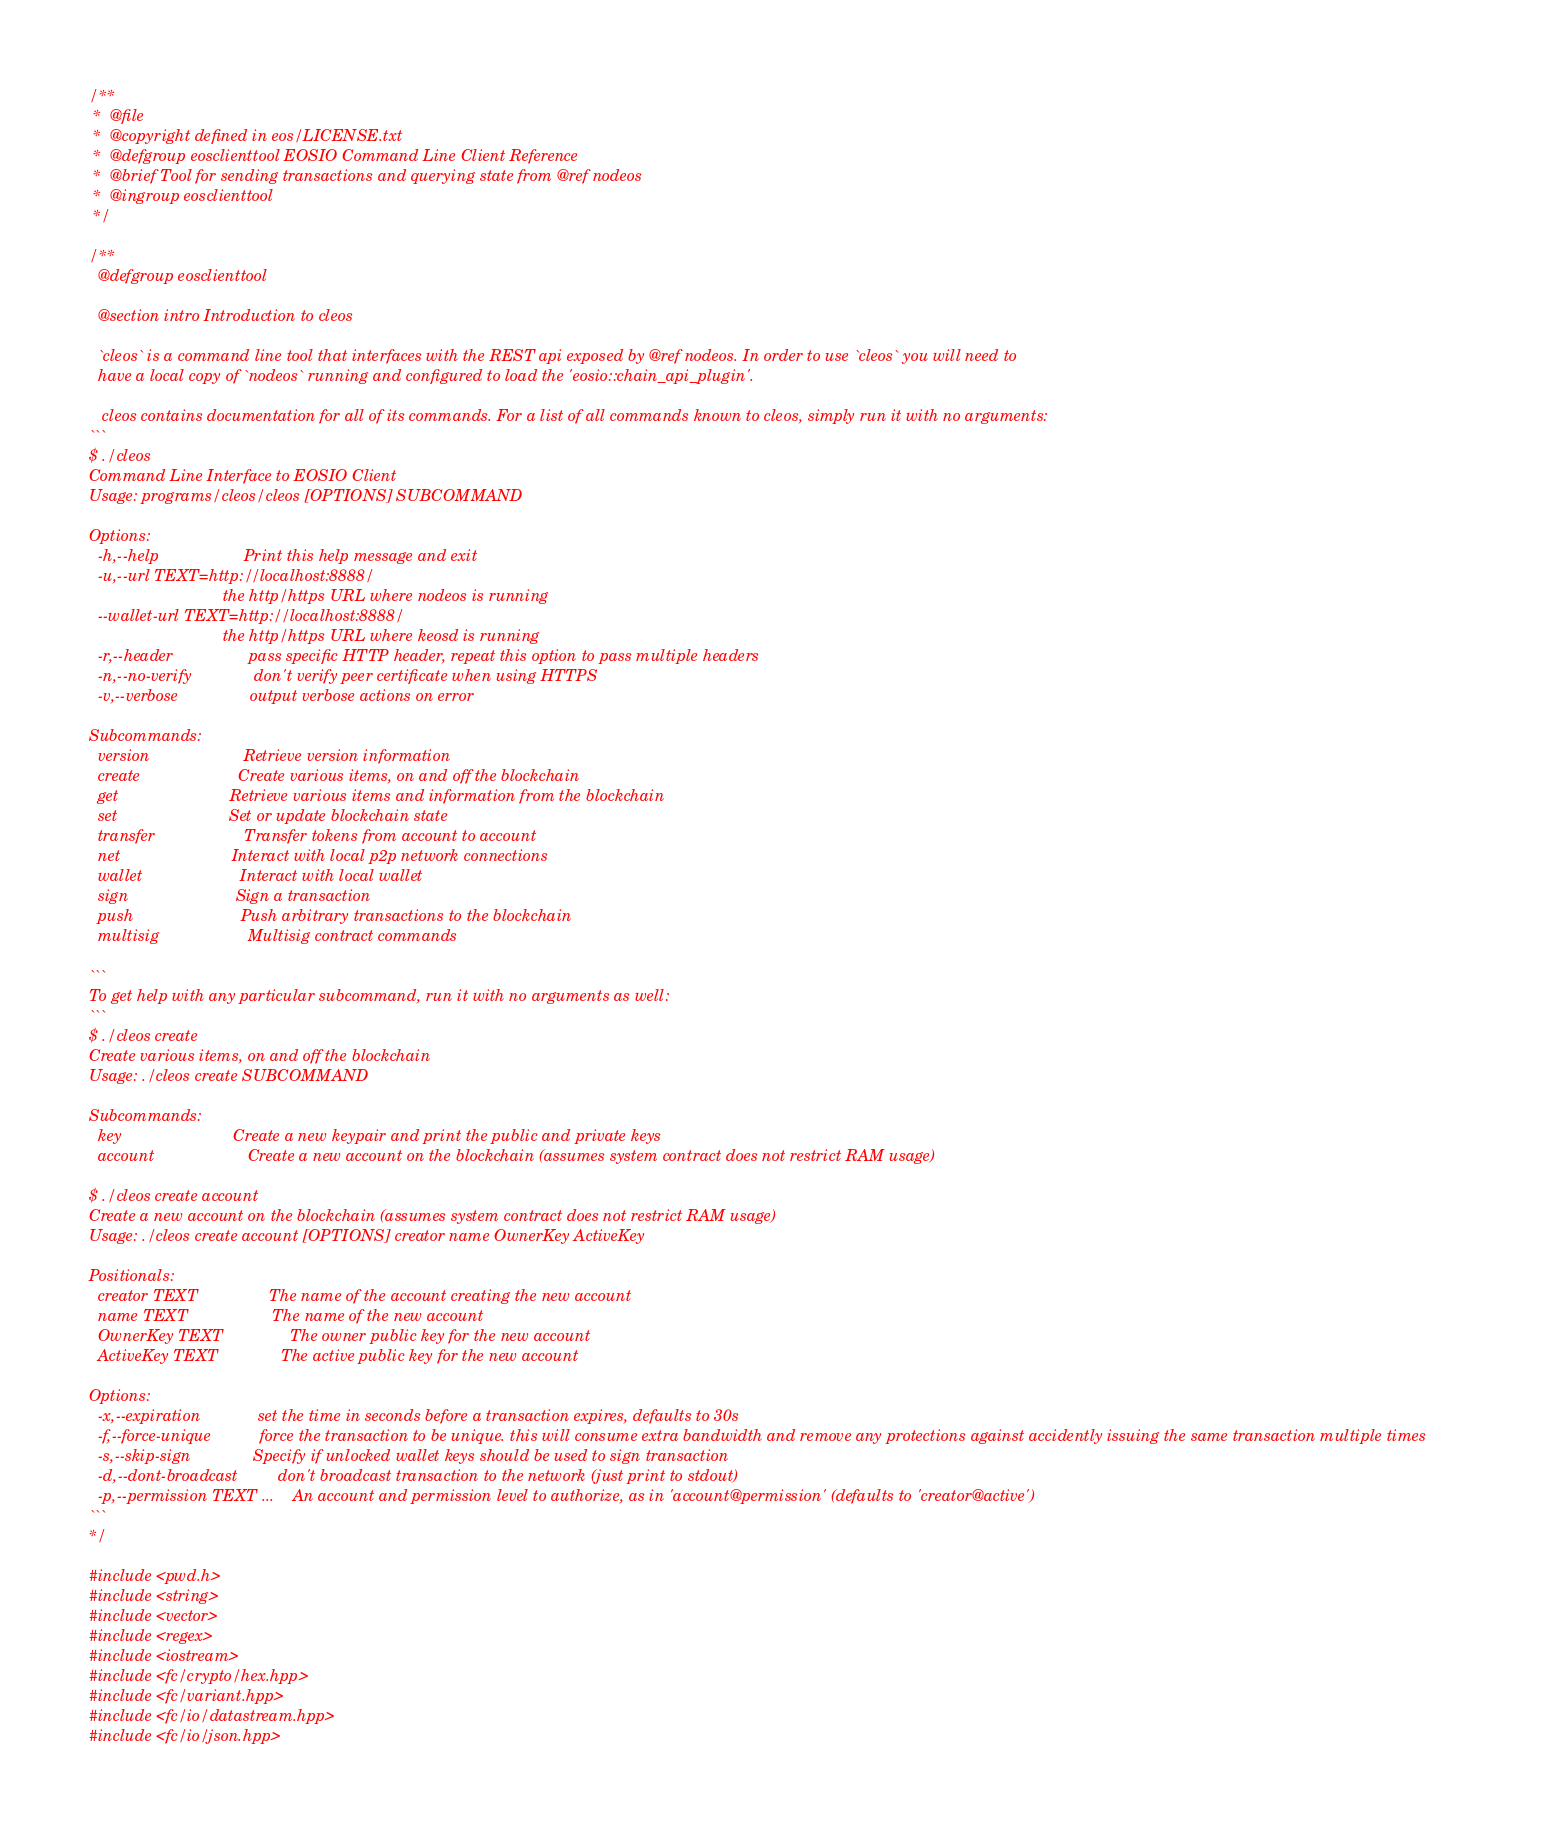<code> <loc_0><loc_0><loc_500><loc_500><_C++_>/**
 *  @file
 *  @copyright defined in eos/LICENSE.txt
 *  @defgroup eosclienttool EOSIO Command Line Client Reference
 *  @brief Tool for sending transactions and querying state from @ref nodeos
 *  @ingroup eosclienttool
 */

/**
  @defgroup eosclienttool

  @section intro Introduction to cleos

  `cleos` is a command line tool that interfaces with the REST api exposed by @ref nodeos. In order to use `cleos` you will need to
  have a local copy of `nodeos` running and configured to load the 'eosio::chain_api_plugin'.

   cleos contains documentation for all of its commands. For a list of all commands known to cleos, simply run it with no arguments:
```
$ ./cleos
Command Line Interface to EOSIO Client
Usage: programs/cleos/cleos [OPTIONS] SUBCOMMAND

Options:
  -h,--help                   Print this help message and exit
  -u,--url TEXT=http://localhost:8888/
                              the http/https URL where nodeos is running
  --wallet-url TEXT=http://localhost:8888/
                              the http/https URL where keosd is running
  -r,--header                 pass specific HTTP header, repeat this option to pass multiple headers
  -n,--no-verify              don't verify peer certificate when using HTTPS
  -v,--verbose                output verbose actions on error

Subcommands:
  version                     Retrieve version information
  create                      Create various items, on and off the blockchain
  get                         Retrieve various items and information from the blockchain
  set                         Set or update blockchain state
  transfer                    Transfer tokens from account to account
  net                         Interact with local p2p network connections
  wallet                      Interact with local wallet
  sign                        Sign a transaction
  push                        Push arbitrary transactions to the blockchain
  multisig                    Multisig contract commands

```
To get help with any particular subcommand, run it with no arguments as well:
```
$ ./cleos create
Create various items, on and off the blockchain
Usage: ./cleos create SUBCOMMAND

Subcommands:
  key                         Create a new keypair and print the public and private keys
  account                     Create a new account on the blockchain (assumes system contract does not restrict RAM usage)

$ ./cleos create account
Create a new account on the blockchain (assumes system contract does not restrict RAM usage)
Usage: ./cleos create account [OPTIONS] creator name OwnerKey ActiveKey

Positionals:
  creator TEXT                The name of the account creating the new account
  name TEXT                   The name of the new account
  OwnerKey TEXT               The owner public key for the new account
  ActiveKey TEXT              The active public key for the new account

Options:
  -x,--expiration             set the time in seconds before a transaction expires, defaults to 30s
  -f,--force-unique           force the transaction to be unique. this will consume extra bandwidth and remove any protections against accidently issuing the same transaction multiple times
  -s,--skip-sign              Specify if unlocked wallet keys should be used to sign transaction
  -d,--dont-broadcast         don't broadcast transaction to the network (just print to stdout)
  -p,--permission TEXT ...    An account and permission level to authorize, as in 'account@permission' (defaults to 'creator@active')
```
*/

#include <pwd.h>
#include <string>
#include <vector>
#include <regex>
#include <iostream>
#include <fc/crypto/hex.hpp>
#include <fc/variant.hpp>
#include <fc/io/datastream.hpp>
#include <fc/io/json.hpp></code> 